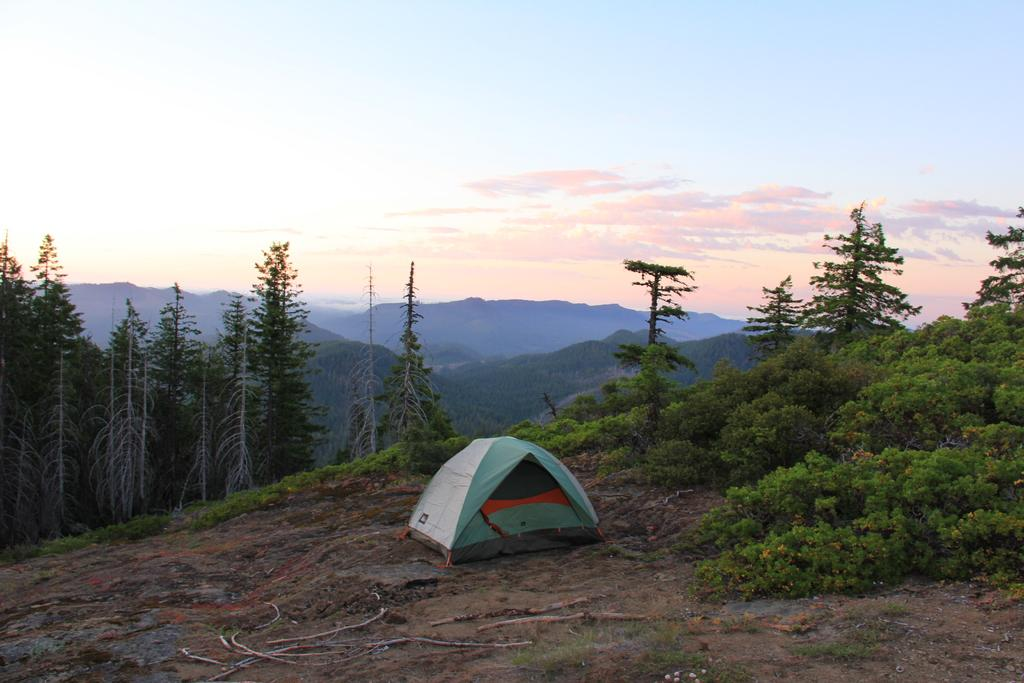What structure is located at the front of the image? There is a tent in the image. Where is the tent positioned in relation to the other elements in the image? The tent is at the front of the image. What can be seen in the background of the image? There are trees, mountains, and the sky visible in the background of the image. What type of chair is placed next to the tent in the image? There is no chair present in the image; it only features a tent and the background elements. 